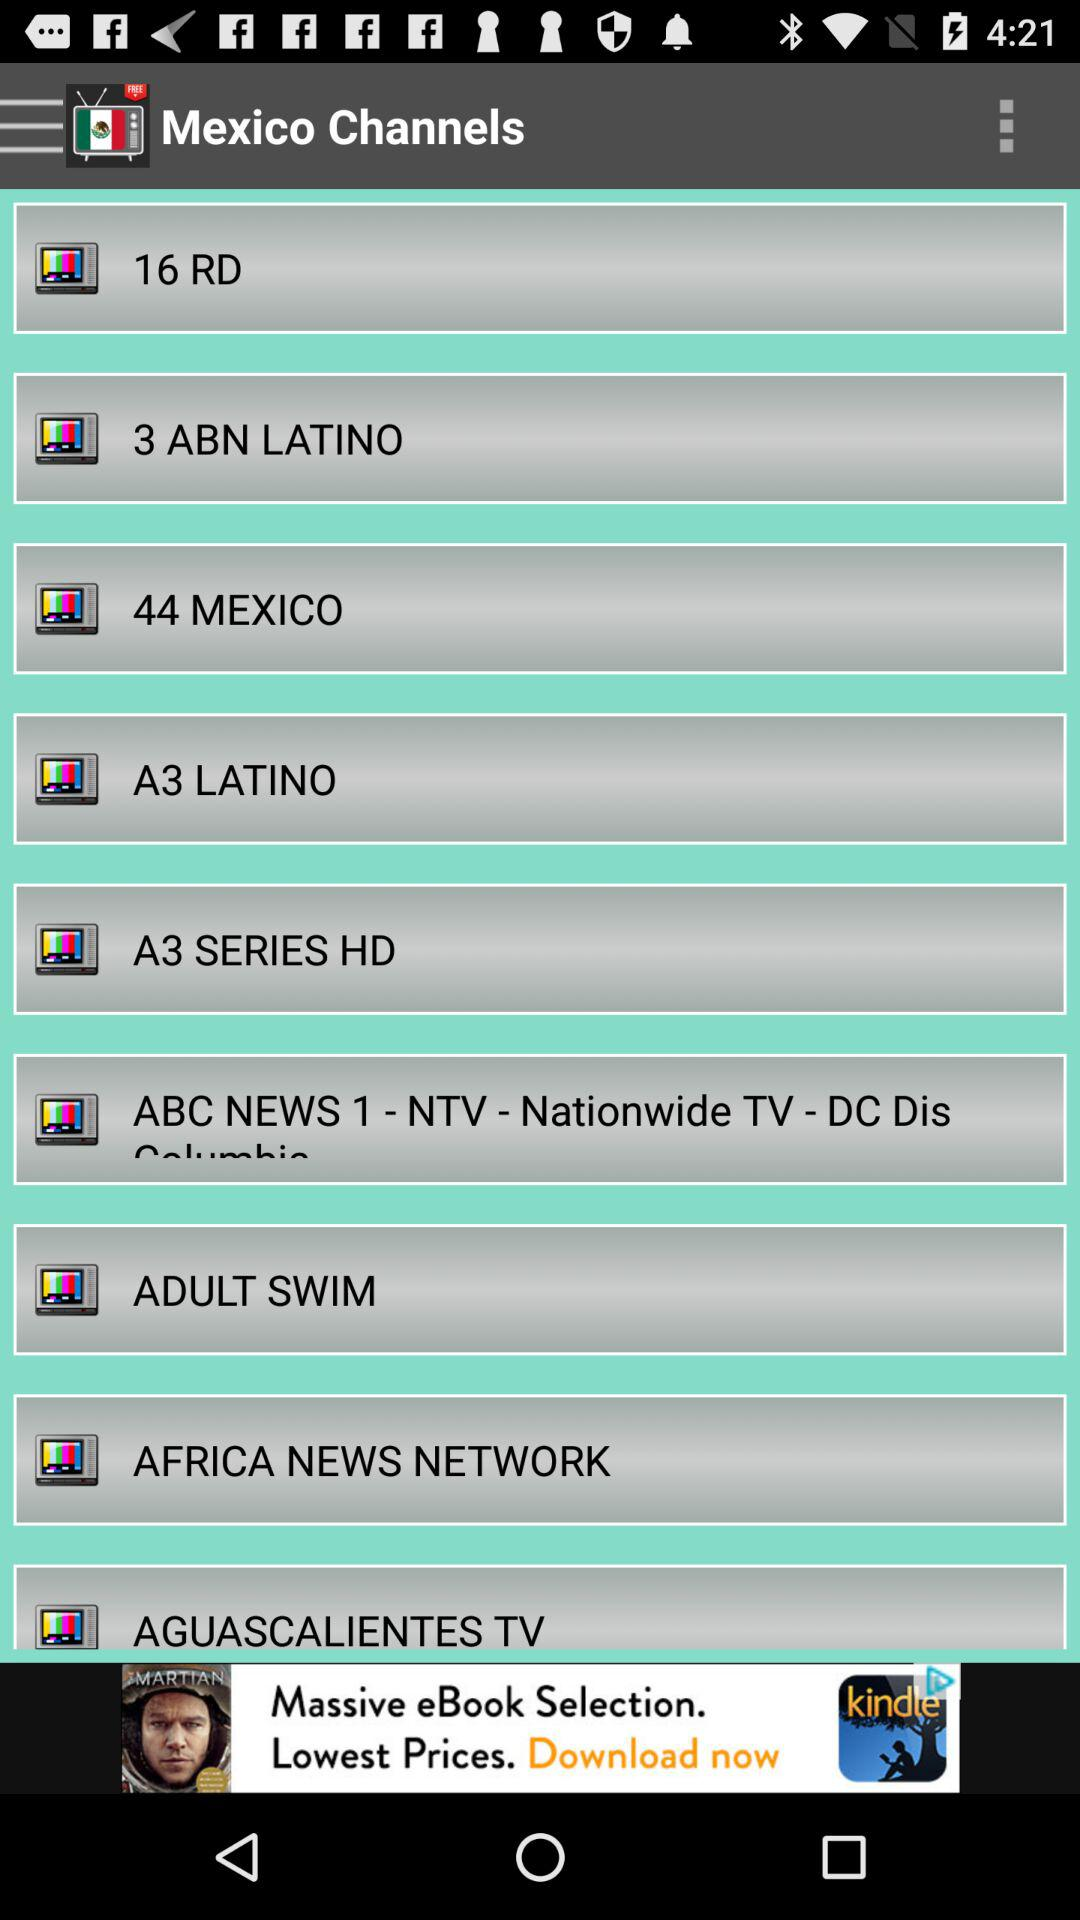What is the country name? The country name is Mexico. 